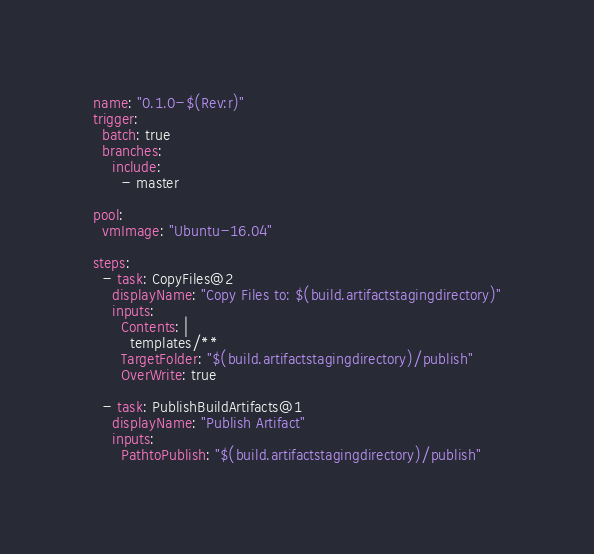Convert code to text. <code><loc_0><loc_0><loc_500><loc_500><_YAML_>name: "0.1.0-$(Rev:r)"
trigger:
  batch: true
  branches:
    include:
      - master

pool:
  vmImage: "Ubuntu-16.04"

steps:
  - task: CopyFiles@2
    displayName: "Copy Files to: $(build.artifactstagingdirectory)"
    inputs:
      Contents: |
        templates/**
      TargetFolder: "$(build.artifactstagingdirectory)/publish"
      OverWrite: true

  - task: PublishBuildArtifacts@1
    displayName: "Publish Artifact"
    inputs:
      PathtoPublish: "$(build.artifactstagingdirectory)/publish"
</code> 